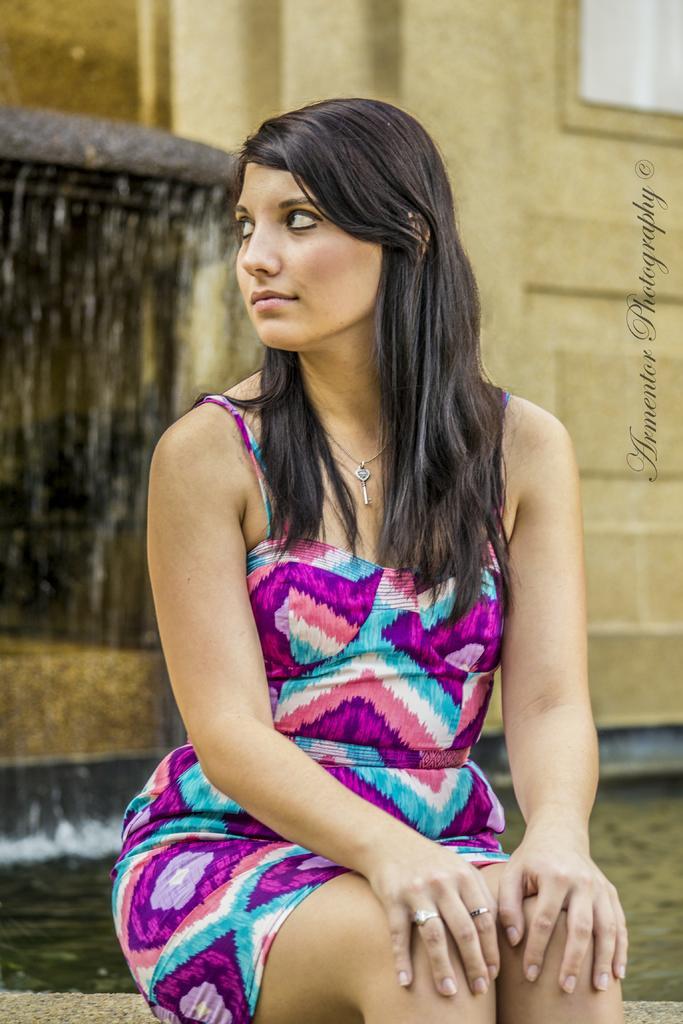Could you give a brief overview of what you see in this image? In this image there is a woman sitting. Behind her there is the water. To the left there is a water fountain. To the right there is a wall. There is text to the right of the image. 